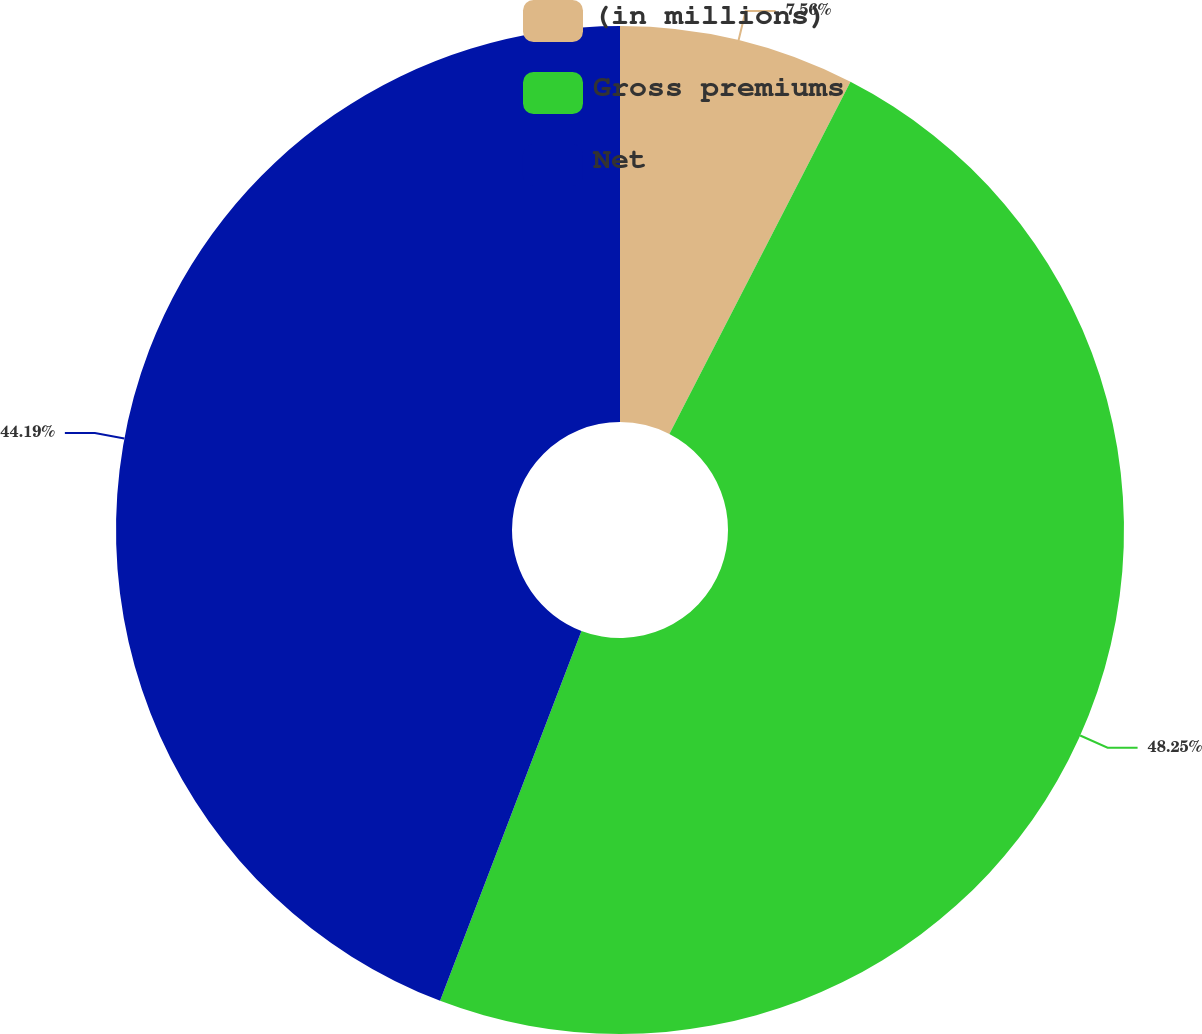Convert chart. <chart><loc_0><loc_0><loc_500><loc_500><pie_chart><fcel>(in millions)<fcel>Gross premiums<fcel>Net<nl><fcel>7.56%<fcel>48.25%<fcel>44.19%<nl></chart> 